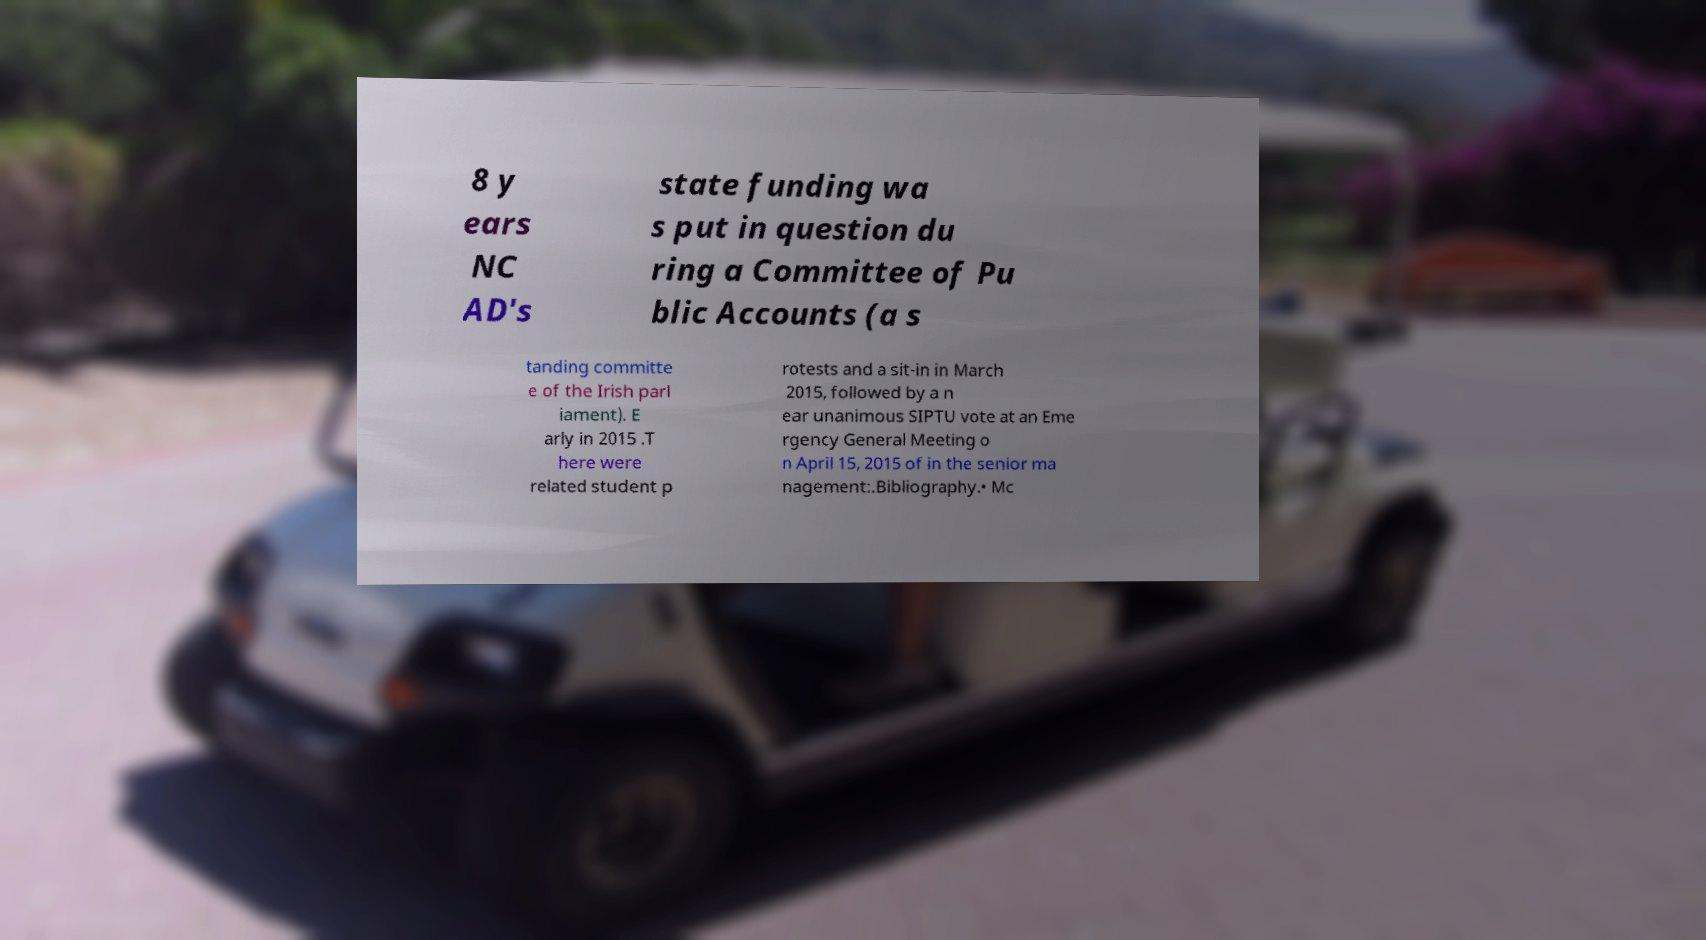Can you read and provide the text displayed in the image?This photo seems to have some interesting text. Can you extract and type it out for me? 8 y ears NC AD's state funding wa s put in question du ring a Committee of Pu blic Accounts (a s tanding committe e of the Irish parl iament). E arly in 2015 .T here were related student p rotests and a sit-in in March 2015, followed by a n ear unanimous SIPTU vote at an Eme rgency General Meeting o n April 15, 2015 of in the senior ma nagement:.Bibliography.• Mc 